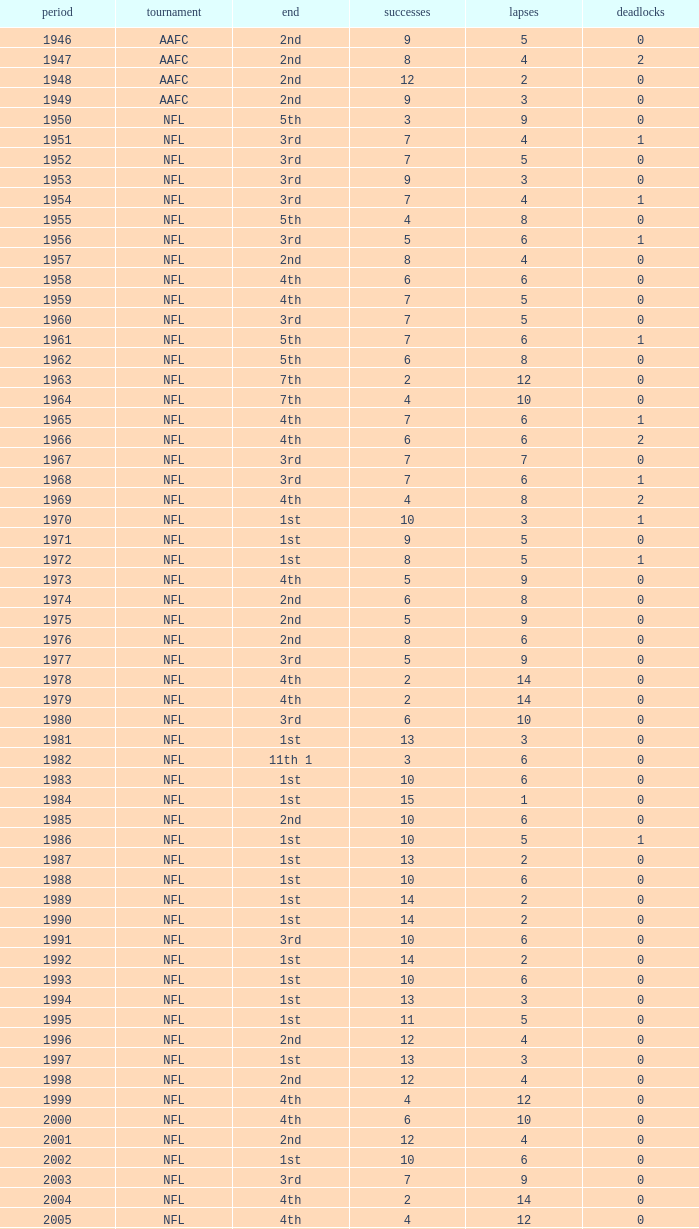What is the highest wins for the NFL with a finish of 1st, and more than 6 losses? None. Would you be able to parse every entry in this table? {'header': ['period', 'tournament', 'end', 'successes', 'lapses', 'deadlocks'], 'rows': [['1946', 'AAFC', '2nd', '9', '5', '0'], ['1947', 'AAFC', '2nd', '8', '4', '2'], ['1948', 'AAFC', '2nd', '12', '2', '0'], ['1949', 'AAFC', '2nd', '9', '3', '0'], ['1950', 'NFL', '5th', '3', '9', '0'], ['1951', 'NFL', '3rd', '7', '4', '1'], ['1952', 'NFL', '3rd', '7', '5', '0'], ['1953', 'NFL', '3rd', '9', '3', '0'], ['1954', 'NFL', '3rd', '7', '4', '1'], ['1955', 'NFL', '5th', '4', '8', '0'], ['1956', 'NFL', '3rd', '5', '6', '1'], ['1957', 'NFL', '2nd', '8', '4', '0'], ['1958', 'NFL', '4th', '6', '6', '0'], ['1959', 'NFL', '4th', '7', '5', '0'], ['1960', 'NFL', '3rd', '7', '5', '0'], ['1961', 'NFL', '5th', '7', '6', '1'], ['1962', 'NFL', '5th', '6', '8', '0'], ['1963', 'NFL', '7th', '2', '12', '0'], ['1964', 'NFL', '7th', '4', '10', '0'], ['1965', 'NFL', '4th', '7', '6', '1'], ['1966', 'NFL', '4th', '6', '6', '2'], ['1967', 'NFL', '3rd', '7', '7', '0'], ['1968', 'NFL', '3rd', '7', '6', '1'], ['1969', 'NFL', '4th', '4', '8', '2'], ['1970', 'NFL', '1st', '10', '3', '1'], ['1971', 'NFL', '1st', '9', '5', '0'], ['1972', 'NFL', '1st', '8', '5', '1'], ['1973', 'NFL', '4th', '5', '9', '0'], ['1974', 'NFL', '2nd', '6', '8', '0'], ['1975', 'NFL', '2nd', '5', '9', '0'], ['1976', 'NFL', '2nd', '8', '6', '0'], ['1977', 'NFL', '3rd', '5', '9', '0'], ['1978', 'NFL', '4th', '2', '14', '0'], ['1979', 'NFL', '4th', '2', '14', '0'], ['1980', 'NFL', '3rd', '6', '10', '0'], ['1981', 'NFL', '1st', '13', '3', '0'], ['1982', 'NFL', '11th 1', '3', '6', '0'], ['1983', 'NFL', '1st', '10', '6', '0'], ['1984', 'NFL', '1st', '15', '1', '0'], ['1985', 'NFL', '2nd', '10', '6', '0'], ['1986', 'NFL', '1st', '10', '5', '1'], ['1987', 'NFL', '1st', '13', '2', '0'], ['1988', 'NFL', '1st', '10', '6', '0'], ['1989', 'NFL', '1st', '14', '2', '0'], ['1990', 'NFL', '1st', '14', '2', '0'], ['1991', 'NFL', '3rd', '10', '6', '0'], ['1992', 'NFL', '1st', '14', '2', '0'], ['1993', 'NFL', '1st', '10', '6', '0'], ['1994', 'NFL', '1st', '13', '3', '0'], ['1995', 'NFL', '1st', '11', '5', '0'], ['1996', 'NFL', '2nd', '12', '4', '0'], ['1997', 'NFL', '1st', '13', '3', '0'], ['1998', 'NFL', '2nd', '12', '4', '0'], ['1999', 'NFL', '4th', '4', '12', '0'], ['2000', 'NFL', '4th', '6', '10', '0'], ['2001', 'NFL', '2nd', '12', '4', '0'], ['2002', 'NFL', '1st', '10', '6', '0'], ['2003', 'NFL', '3rd', '7', '9', '0'], ['2004', 'NFL', '4th', '2', '14', '0'], ['2005', 'NFL', '4th', '4', '12', '0'], ['2006', 'NFL', '3rd', '7', '9', '0'], ['2007', 'NFL', '3rd', '5', '11', '0'], ['2008', 'NFL', '2nd', '7', '9', '0'], ['2009', 'NFL', '2nd', '8', '8', '0'], ['2010', 'NFL', '3rd', '6', '10', '0'], ['2011', 'NFL', '1st', '13', '3', '0'], ['2012', 'NFL', '1st', '11', '4', '1'], ['2013', 'NFL', '2nd', '6', '2', '0']]} 